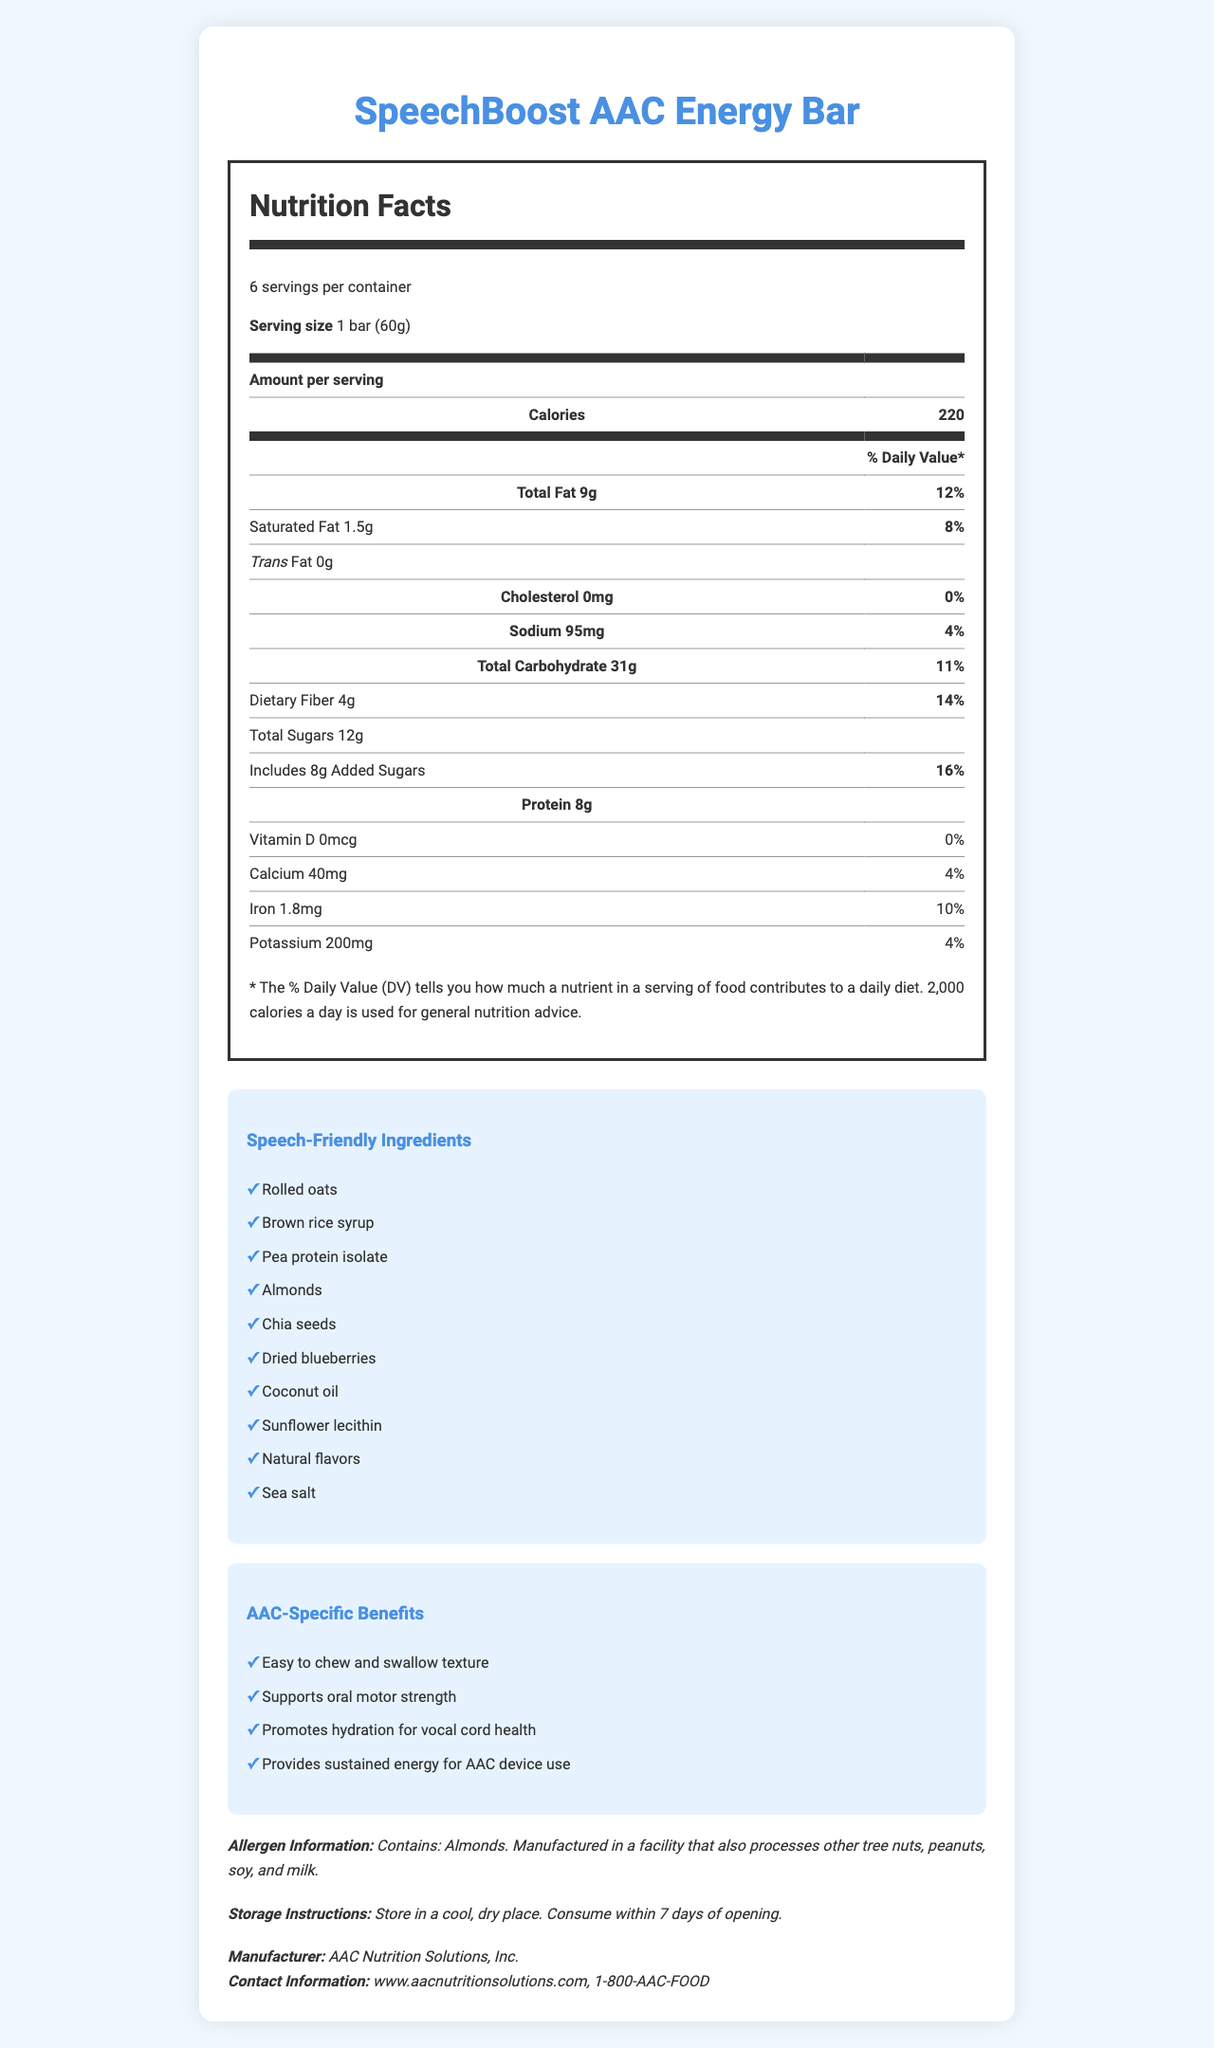what is the serving size of the SpeechBoost AAC Energy Bar? The serving size is mentioned under "Serving size" in the Nutrition Facts section.
Answer: 1 bar (60g) how many calories does each serving of the SpeechBoost AAC Energy Bar contain? The calorie content per serving is noted as 220 under the "Calories" section in the Nutrition Facts.
Answer: 220 what percentage of the daily value is provided by total fat per serving? The daily value percentage for total fat is listed next to the total fat amount in the Nutrition Facts section.
Answer: 12% what speech-friendly ingredients are included in the SpeechBoost AAC Energy Bar? These ingredients are listed under the "Speech-Friendly Ingredients" section.
Answer: Rolled oats, Brown rice syrup, Pea protein isolate, Almonds, Chia seeds, Dried blueberries, Coconut oil, Sunflower lecithin, Natural flavors, Sea salt how much sodium is in one serving of the SpeechBoost AAC Energy Bar? The sodium content per serving is clearly listed as 95mg in the Nutrition Facts section.
Answer: 95mg which of the following best describes the texture of the SpeechBoost AAC Energy Bar based on its AAC-specific benefits?
A. Hard and crunchy
B. Soft and chewy
C. Powdery and dry
D. Thick and sticky One of the AAC-specific benefits is "Easy to chew and swallow texture," which indicates a soft and chewy texture.
Answer: B what is the dietary fiber content in one serving, and what percentage of the daily value does this represent? The dietary fiber content is 4g, and it represents 14% of the daily value according to the Nutrition Facts section.
Answer: 4g, 14% does the SpeechBoost AAC Energy Bar contain any trans fat? It is clearly stated as "Trans Fat 0g" under the total fat subsection in the Nutrition Facts.
Answer: No is dried blueberries one of the speech-friendly ingredients? Dried blueberries are listed under the speech-friendly ingredients.
Answer: Yes are there any allergens in the SpeechBoost AAC Energy Bar? If so, what are they? The allergen information indicates that the bar contains almonds and is manufactured in a facility that processes other tree nuts, peanuts, soy, and milk.
Answer: Yes, almonds which of the following is a specific benefit for AAC users of this energy bar?
I. Supports oral motor strength
II. Promotes heart health
III. Enhances memory recall
IV. Provides sustained energy for AAC device use Both "Supports oral motor strength" and "Provides sustained energy for AAC device use" are listed under "AAC-Specific Benefits."
Answer: I and IV does the SpeechBoost AAC Energy Bar provide any vitamin D? It states "Vitamin D 0mcg" and "0%" in the Nutrition Facts section.
Answer: No describe the main idea of this document. The document presents a detailed breakdown of nutritional content, special ingredients beneficial for speech, and specific features supporting the needs of AAC device users.
Answer: The document provides comprehensive nutrition facts, allergen information, storage instructions, and AAC-specific benefits for the SpeechBoost AAC Energy Bar, highlighting its compatibility for speech-language therapy and AAC device users. can the document tell you where to purchase the SpeechBoost AAC Energy Bar? The document does not provide purchasing information; it only includes manufacturer and contact details.
Answer: Not enough information 